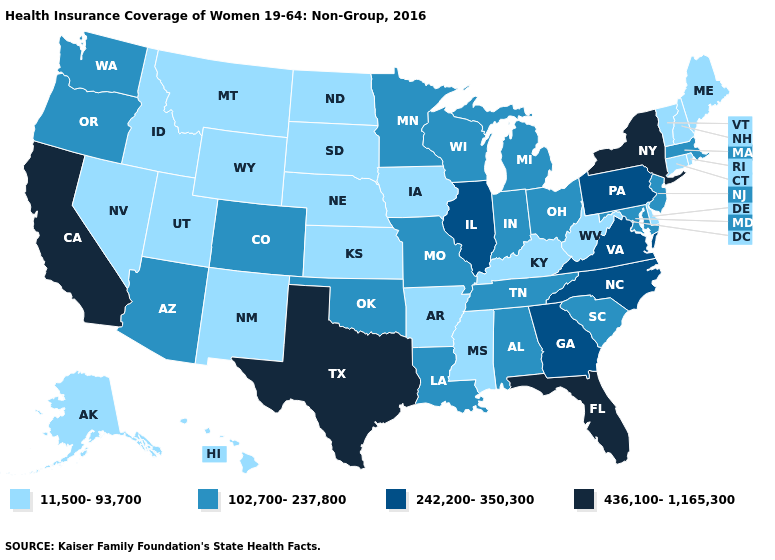Is the legend a continuous bar?
Concise answer only. No. Among the states that border Maine , which have the lowest value?
Keep it brief. New Hampshire. What is the value of Oklahoma?
Answer briefly. 102,700-237,800. Does Ohio have the same value as New York?
Be succinct. No. Name the states that have a value in the range 242,200-350,300?
Write a very short answer. Georgia, Illinois, North Carolina, Pennsylvania, Virginia. How many symbols are there in the legend?
Concise answer only. 4. Does Nebraska have the lowest value in the MidWest?
Keep it brief. Yes. Does Maryland have a higher value than Idaho?
Answer briefly. Yes. How many symbols are there in the legend?
Quick response, please. 4. Which states hav the highest value in the MidWest?
Concise answer only. Illinois. Name the states that have a value in the range 436,100-1,165,300?
Answer briefly. California, Florida, New York, Texas. Does Kentucky have the lowest value in the USA?
Answer briefly. Yes. Among the states that border Louisiana , which have the lowest value?
Short answer required. Arkansas, Mississippi. What is the value of New Hampshire?
Write a very short answer. 11,500-93,700. Name the states that have a value in the range 436,100-1,165,300?
Give a very brief answer. California, Florida, New York, Texas. 